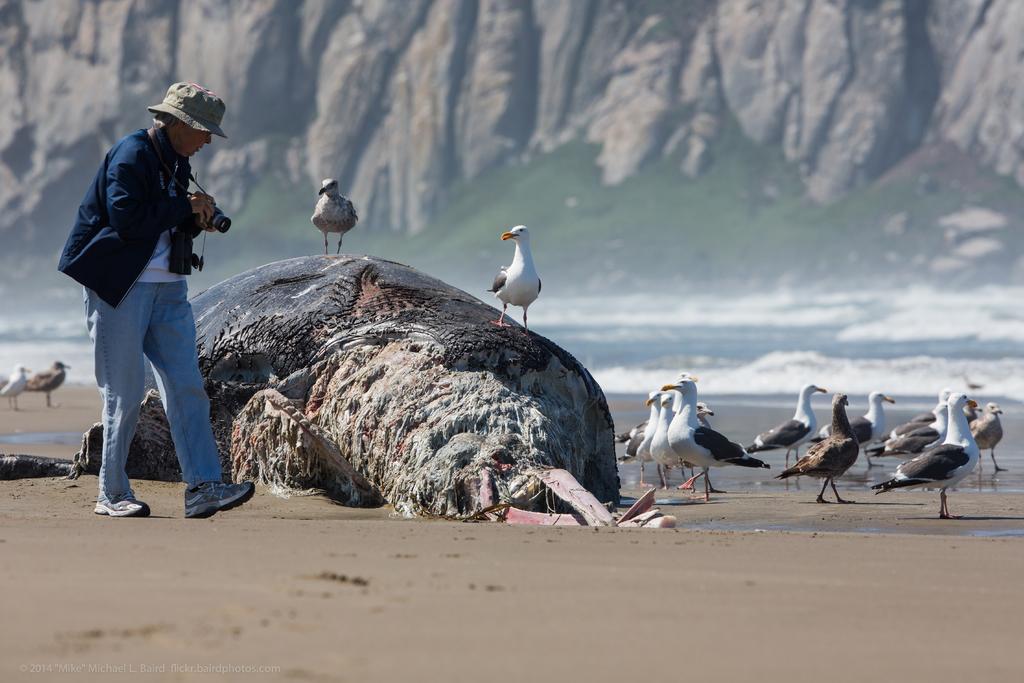Can you describe this image briefly? In this image, I can see a person walking on the sand. I can see the body of a dead whale and there are birds. In the background, I can see the hills and the sea. In the bottom left corner of the image, there is a watermark. 